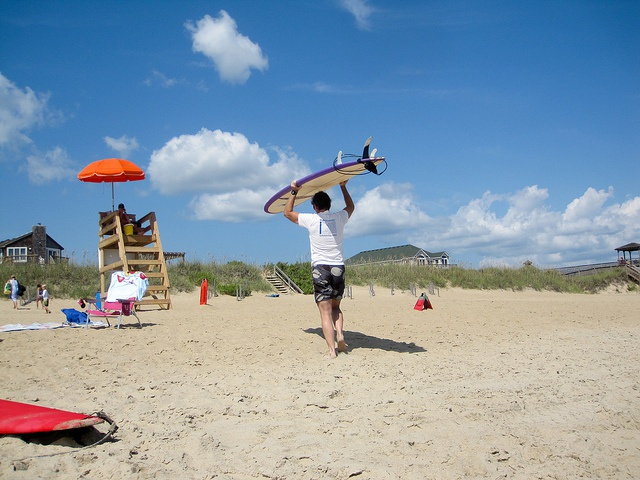Describe the objects in this image and their specific colors. I can see people in blue, lightgray, black, darkgray, and gray tones, chair in blue, tan, gray, and black tones, surfboard in blue, brown, red, and salmon tones, surfboard in blue, tan, purple, and black tones, and chair in blue, white, violet, darkgray, and gray tones in this image. 